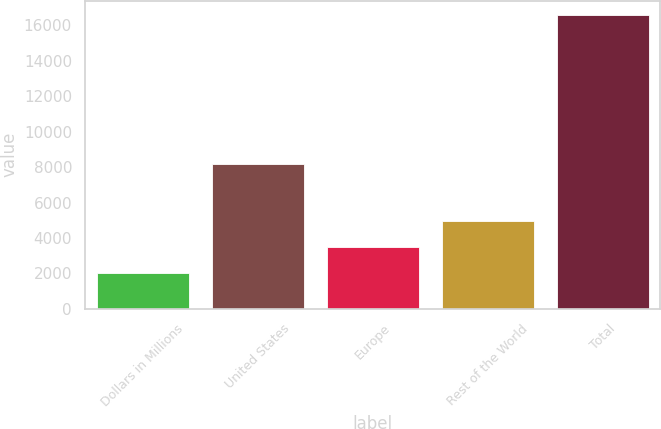Convert chart to OTSL. <chart><loc_0><loc_0><loc_500><loc_500><bar_chart><fcel>Dollars in Millions<fcel>United States<fcel>Europe<fcel>Rest of the World<fcel>Total<nl><fcel>2015<fcel>8188<fcel>3491<fcel>4945.5<fcel>16560<nl></chart> 